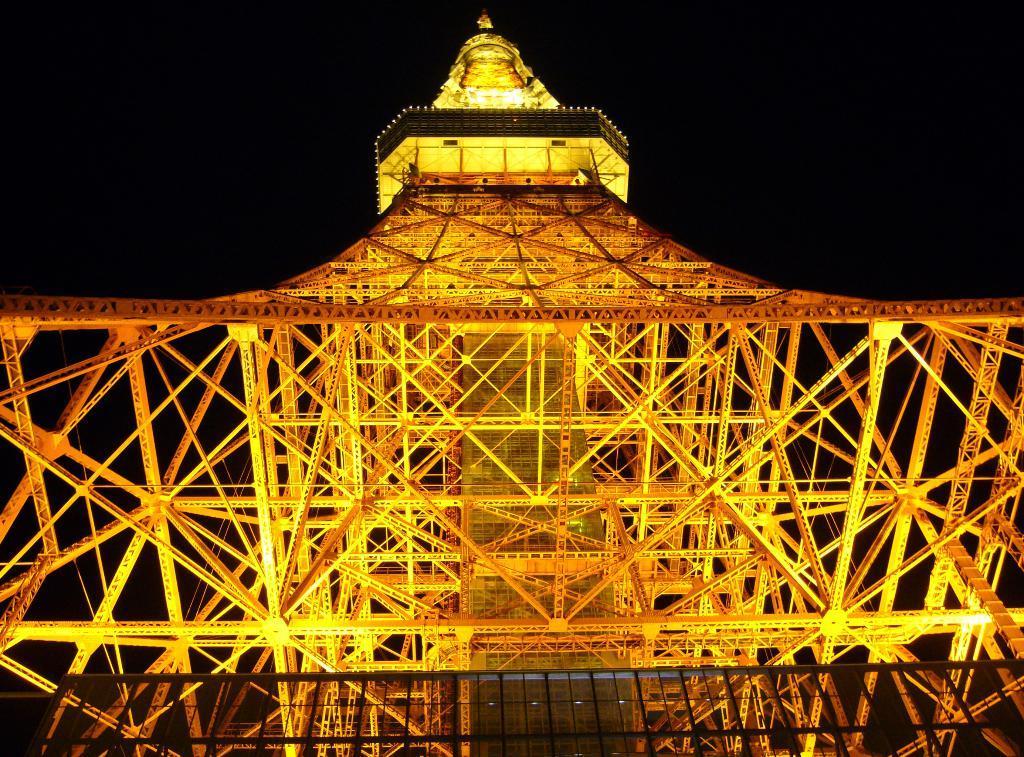Could you give a brief overview of what you see in this image? In this image I can see a huge metal tower which is brown and yellow in color and few lights to it. I can see the dark sky in the background. 